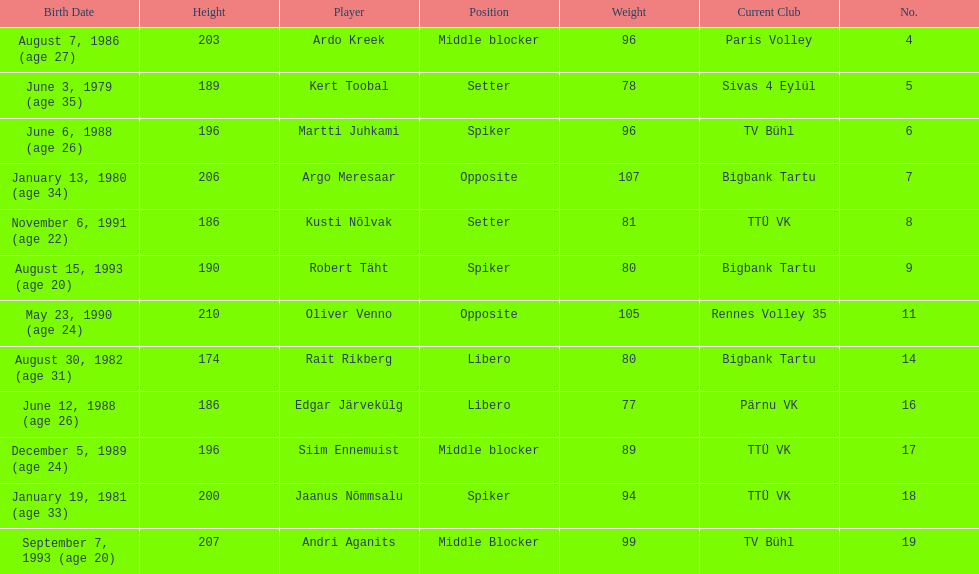Write the full table. {'header': ['Birth Date', 'Height', 'Player', 'Position', 'Weight', 'Current Club', 'No.'], 'rows': [['August 7, 1986 (age\xa027)', '203', 'Ardo Kreek', 'Middle blocker', '96', 'Paris Volley', '4'], ['June 3, 1979 (age\xa035)', '189', 'Kert Toobal', 'Setter', '78', 'Sivas 4 Eylül', '5'], ['June 6, 1988 (age\xa026)', '196', 'Martti Juhkami', 'Spiker', '96', 'TV Bühl', '6'], ['January 13, 1980 (age\xa034)', '206', 'Argo Meresaar', 'Opposite', '107', 'Bigbank Tartu', '7'], ['November 6, 1991 (age\xa022)', '186', 'Kusti Nõlvak', 'Setter', '81', 'TTÜ VK', '8'], ['August 15, 1993 (age\xa020)', '190', 'Robert Täht', 'Spiker', '80', 'Bigbank Tartu', '9'], ['May 23, 1990 (age\xa024)', '210', 'Oliver Venno', 'Opposite', '105', 'Rennes Volley 35', '11'], ['August 30, 1982 (age\xa031)', '174', 'Rait Rikberg', 'Libero', '80', 'Bigbank Tartu', '14'], ['June 12, 1988 (age\xa026)', '186', 'Edgar Järvekülg', 'Libero', '77', 'Pärnu VK', '16'], ['December 5, 1989 (age\xa024)', '196', 'Siim Ennemuist', 'Middle blocker', '89', 'TTÜ VK', '17'], ['January 19, 1981 (age\xa033)', '200', 'Jaanus Nõmmsalu', 'Spiker', '94', 'TTÜ VK', '18'], ['September 7, 1993 (age\xa020)', '207', 'Andri Aganits', 'Middle Blocker', '99', 'TV Bühl', '19']]} How much taller in oliver venno than rait rikberg? 36. 